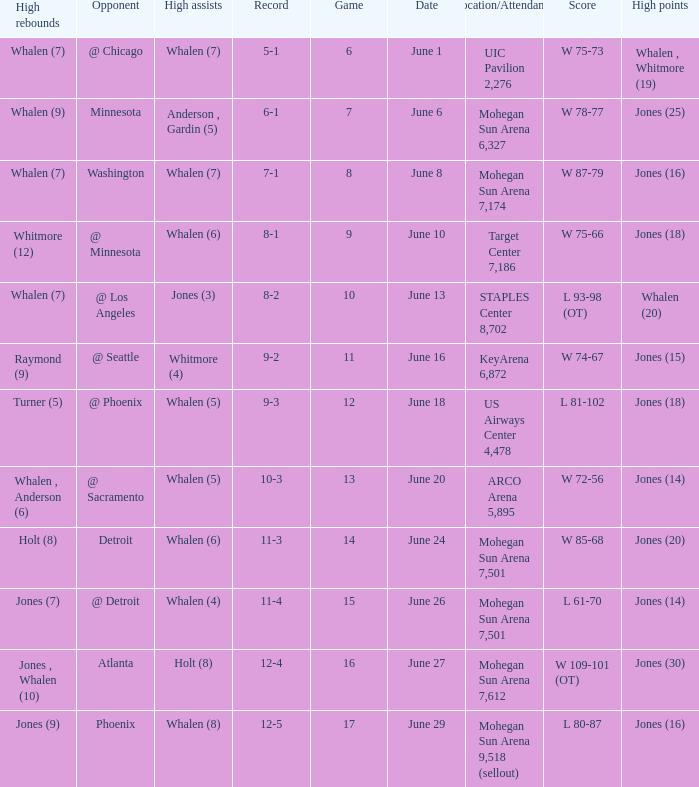Who had the high assists when the game was less than 13 and the score was w 75-66? Whalen (6). 